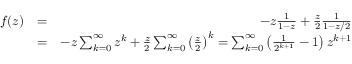<formula> <loc_0><loc_0><loc_500><loc_500>\begin{array} { r l r } { f ( z ) } & { = } & { - z \frac { 1 } { 1 - z } + \frac { z } { 2 } \frac { 1 } { 1 - z / 2 } } \\ & { = } & { - z \sum _ { k = 0 } ^ { \infty } z ^ { k } + \frac { z } { 2 } \sum _ { k = 0 } ^ { \infty } \left ( \frac { z } { 2 } \right ) ^ { k } = \sum _ { k = 0 } ^ { \infty } \left ( \frac { 1 } { 2 ^ { k + 1 } } - 1 \right ) z ^ { k + 1 } } \end{array}</formula> 